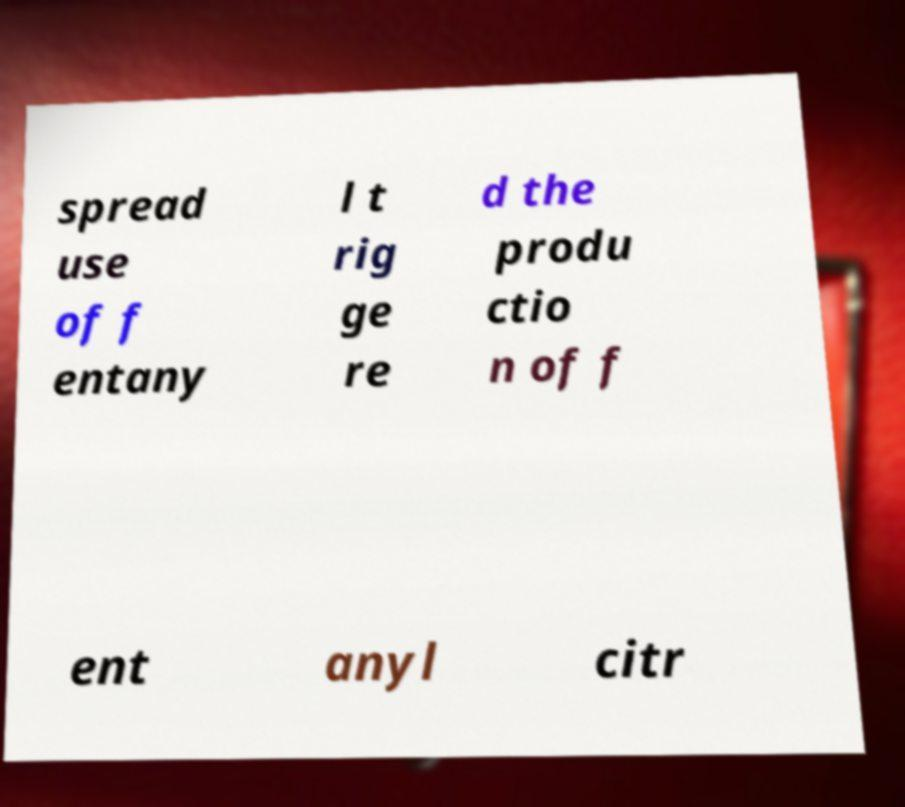For documentation purposes, I need the text within this image transcribed. Could you provide that? spread use of f entany l t rig ge re d the produ ctio n of f ent anyl citr 